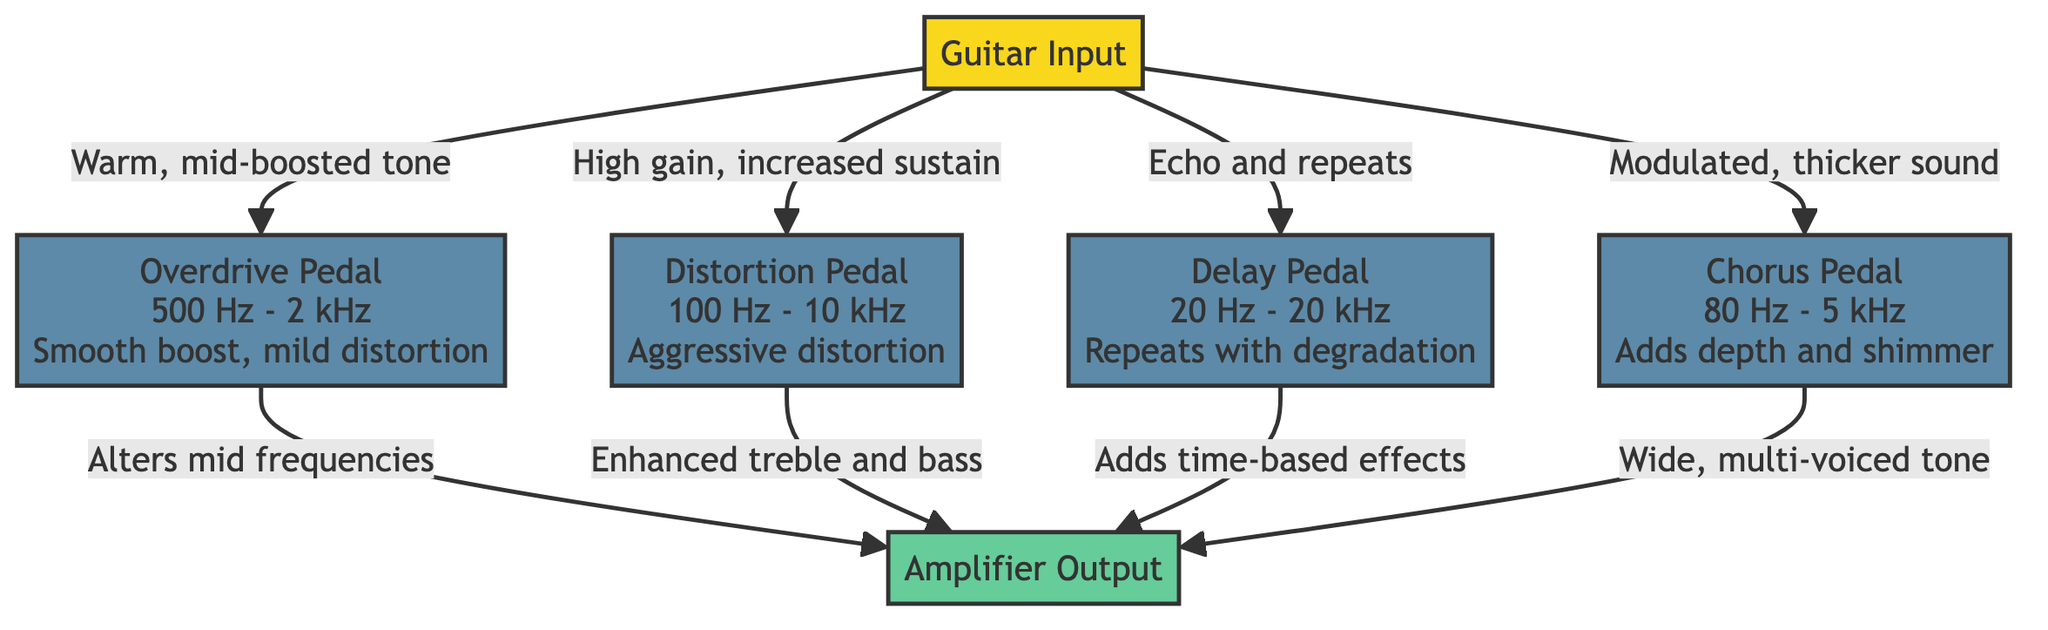What is the frequency range for the Overdrive Pedal? The diagram specifies that the Overdrive Pedal operates between 500 Hz and 2 kHz. This information can be found directly in the node associated with the Overdrive Pedal.
Answer: 500 Hz - 2 kHz How many types of guitar pedals are depicted in the diagram? By analyzing the diagram, we can count four distinct types of guitar pedals: Overdrive, Distortion, Delay, and Chorus. This information is presented in the nodes of the flowchart.
Answer: 4 What sound effect does the Distortion Pedal provide? The Distortion Pedal is described as providing "Aggressive distortion," which is stated in the node related to the Distortion Pedal.
Answer: Aggressive distortion Which pedal is described as adding depth and shimmer? The node for the Chorus Pedal indicates that it adds "depth and shimmer" to the sound, making it the pedal that provides this specific effect.
Answer: Chorus Pedal What is the result of applying the Overdrive Pedal? According to the diagram, applying the Overdrive Pedal results in redirection of the sound to the amplifier output with an "Alters mid frequencies" effect, as specified in the output connection.
Answer: Alters mid frequencies Which pedal has the widest frequency range? The Delay Pedal has the widest range, specified as "20 Hz - 20 kHz" in its node. By comparing the frequency ranges of all pedals, this one exceeds the rest.
Answer: 20 Hz - 20 kHz What is the effect of the Delay Pedal on the sound output? The diagram states that the Delay Pedal adds "time-based effects" to the sound output, which can be traced through the output connection labeled with this description.
Answer: Adds time-based effects Which pedal influences enhanced treble and bass? The Distortion Pedal is noted to enhance treble and bass in the output, which provides the necessary information to identify which pedal has this effect.
Answer: Distortion Pedal 